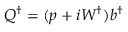<formula> <loc_0><loc_0><loc_500><loc_500>Q ^ { \dagger } = ( p + i W ^ { \dagger } ) b ^ { \dagger }</formula> 